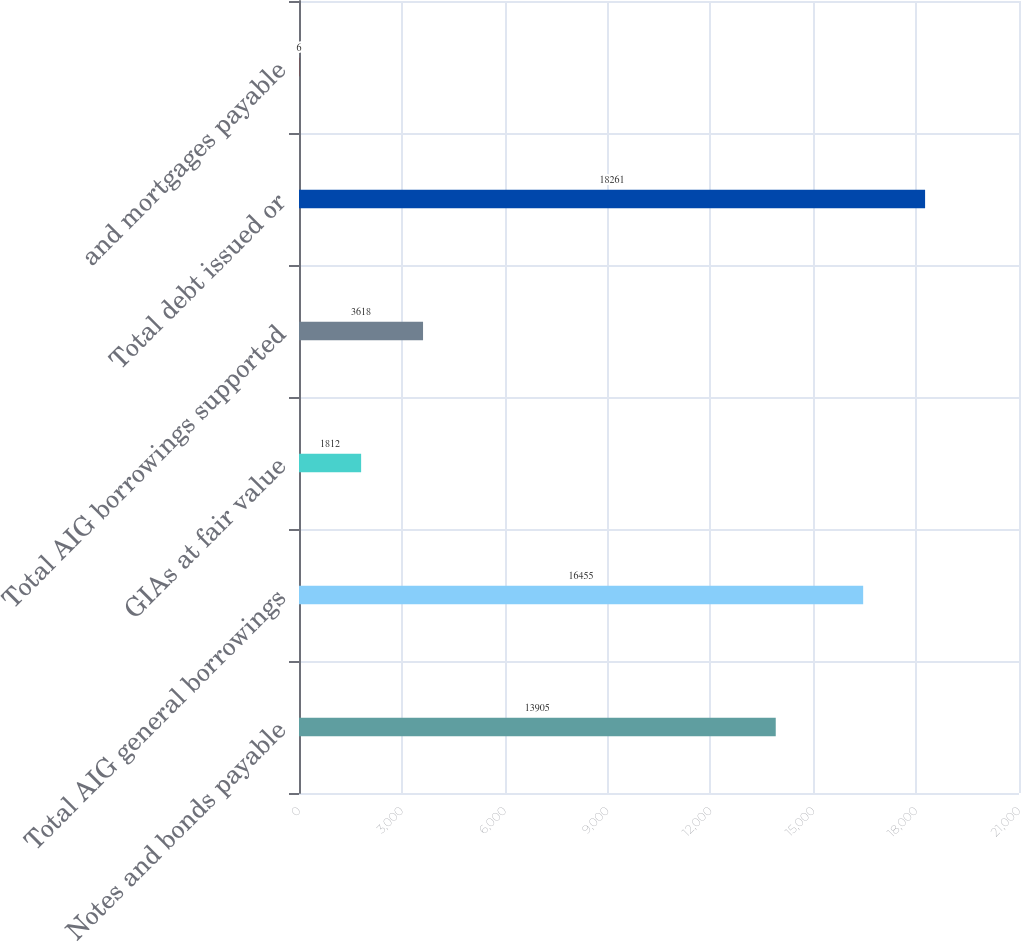Convert chart to OTSL. <chart><loc_0><loc_0><loc_500><loc_500><bar_chart><fcel>Notes and bonds payable<fcel>Total AIG general borrowings<fcel>GIAs at fair value<fcel>Total AIG borrowings supported<fcel>Total debt issued or<fcel>and mortgages payable<nl><fcel>13905<fcel>16455<fcel>1812<fcel>3618<fcel>18261<fcel>6<nl></chart> 